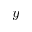Convert formula to latex. <formula><loc_0><loc_0><loc_500><loc_500>y</formula> 